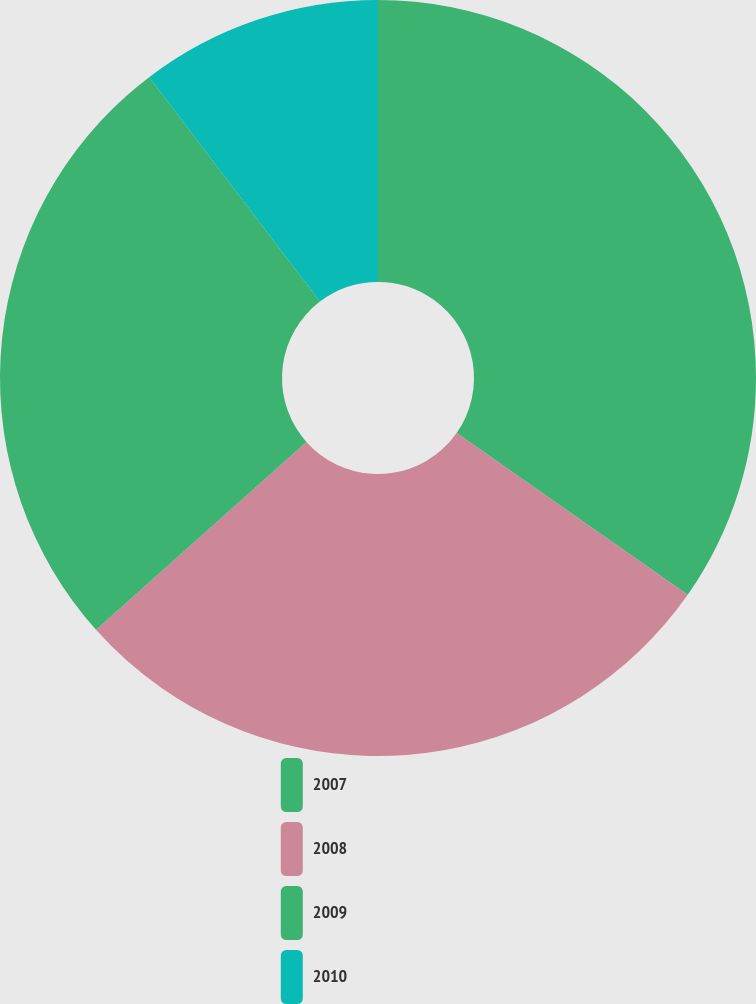Convert chart to OTSL. <chart><loc_0><loc_0><loc_500><loc_500><pie_chart><fcel>2007<fcel>2008<fcel>2009<fcel>2010<nl><fcel>34.72%<fcel>28.68%<fcel>26.25%<fcel>10.35%<nl></chart> 